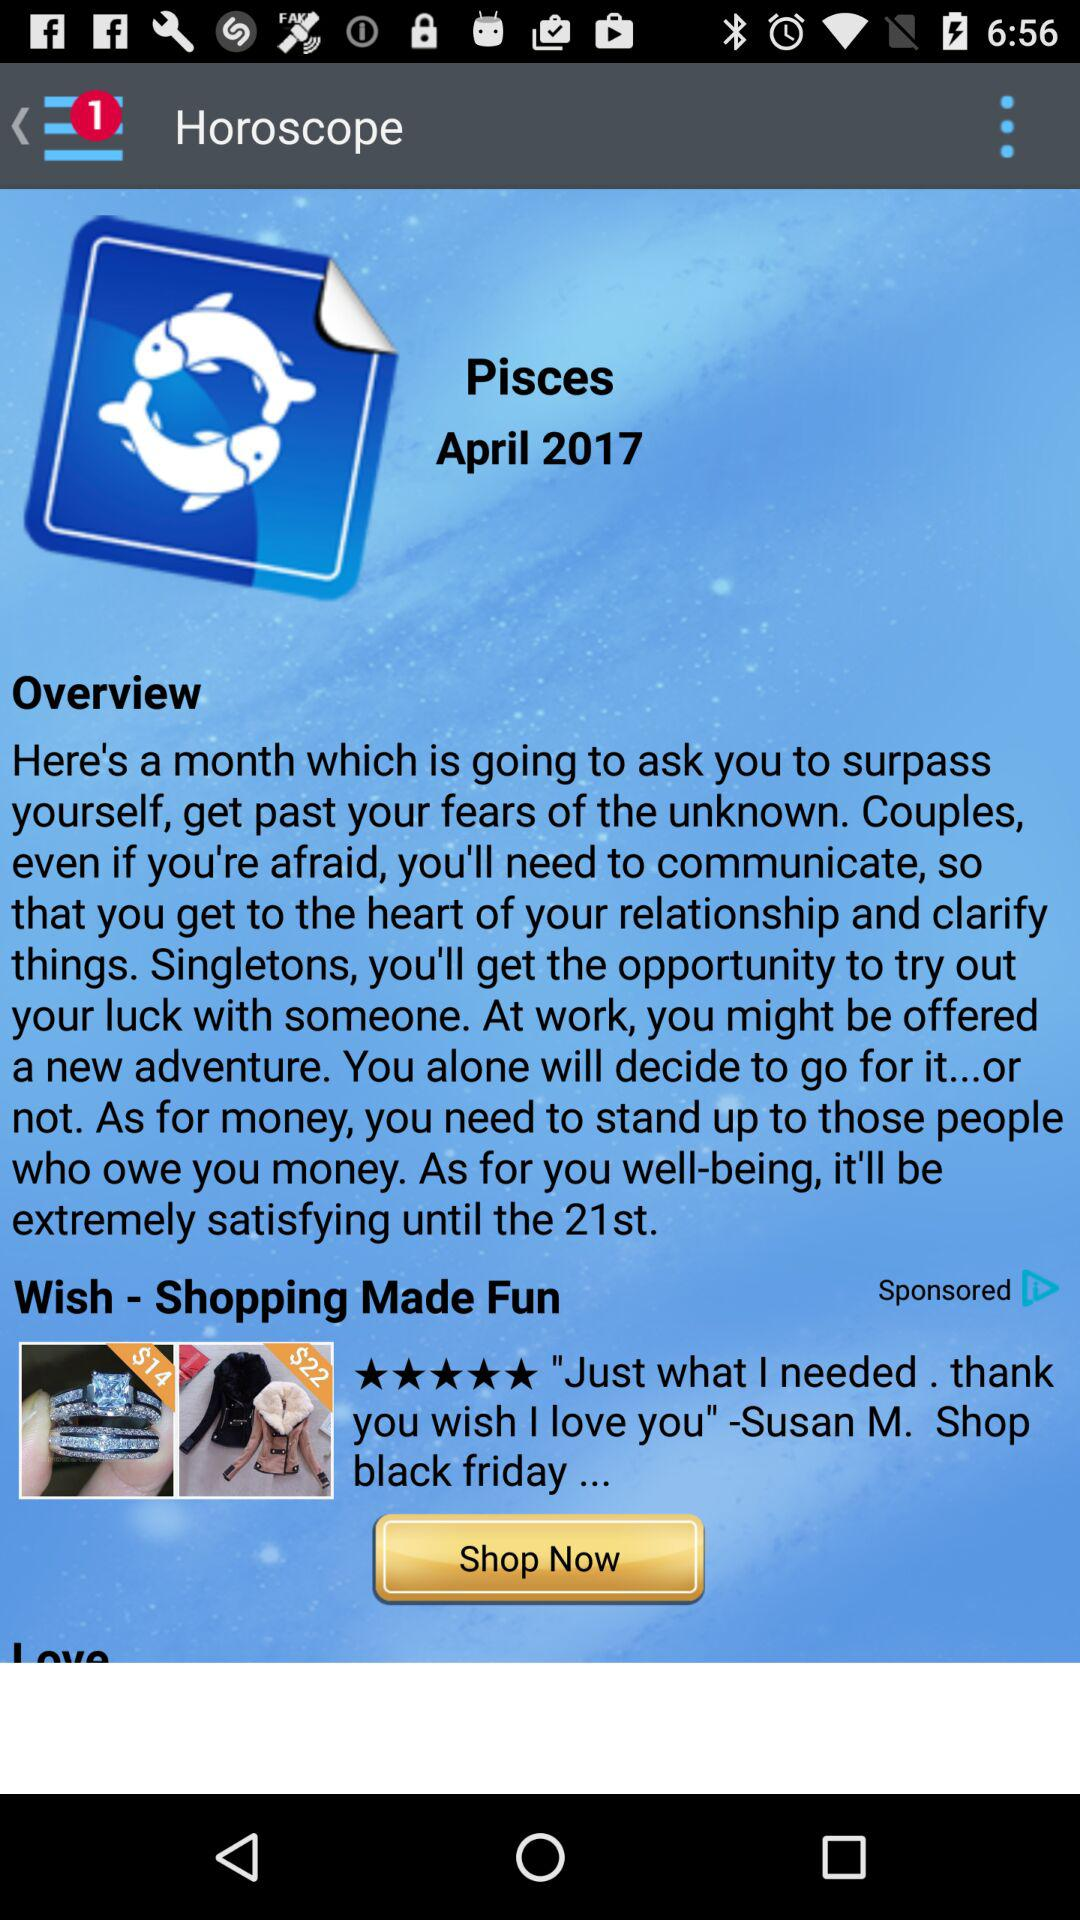What is the name of the application? The name of the application is "Horoscope". 